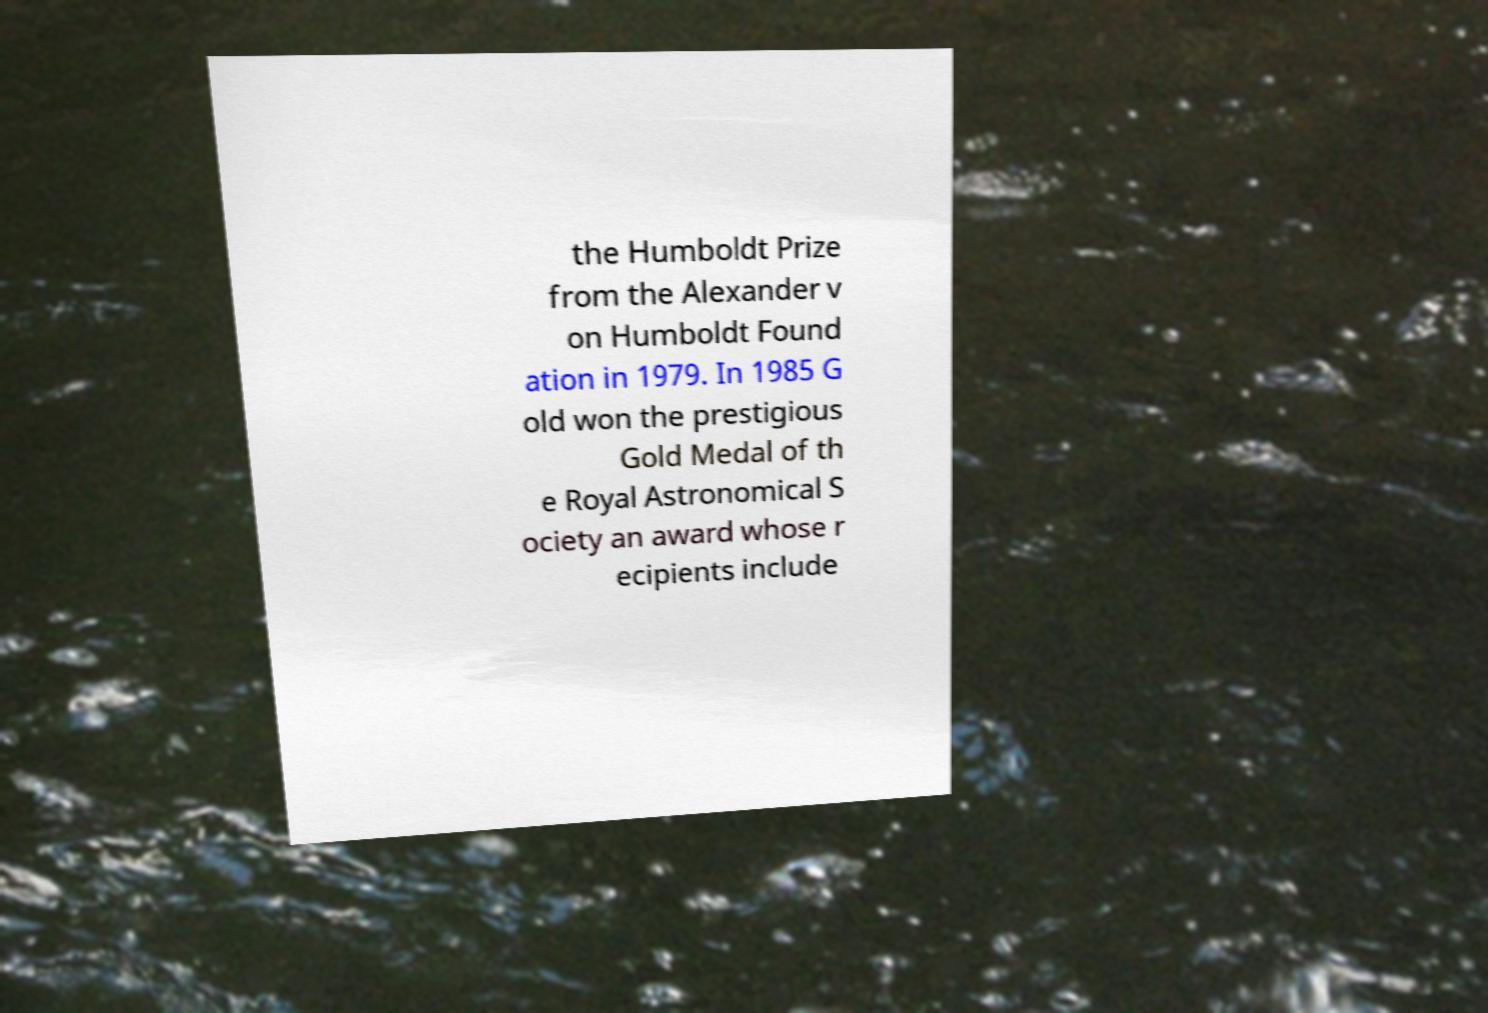For documentation purposes, I need the text within this image transcribed. Could you provide that? the Humboldt Prize from the Alexander v on Humboldt Found ation in 1979. In 1985 G old won the prestigious Gold Medal of th e Royal Astronomical S ociety an award whose r ecipients include 